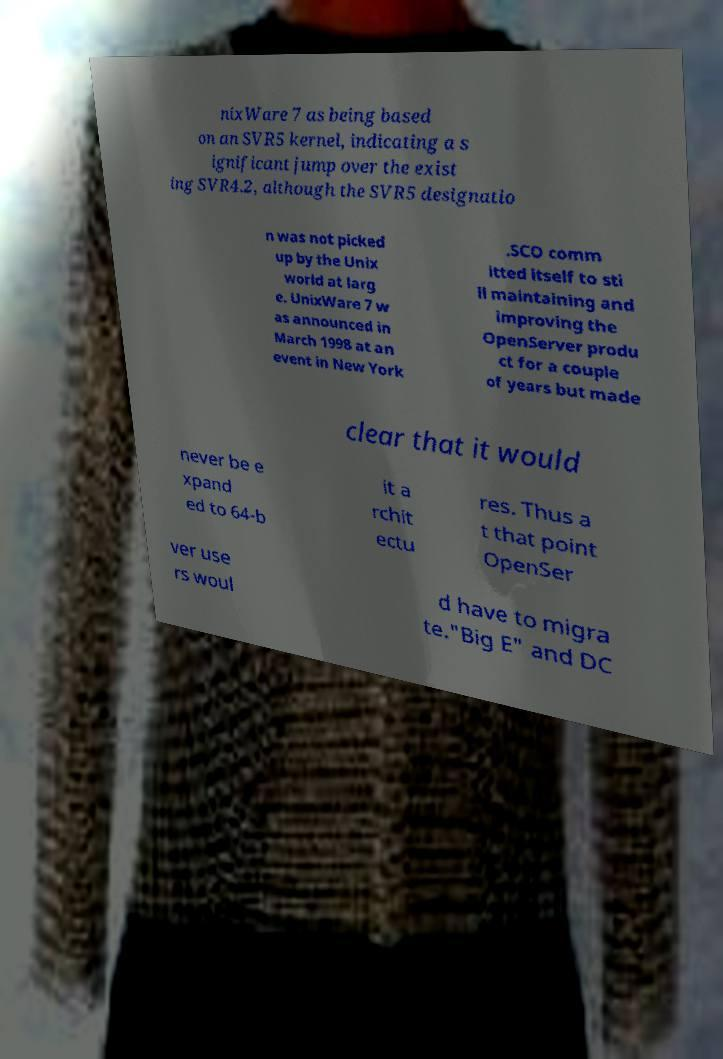What messages or text are displayed in this image? I need them in a readable, typed format. nixWare 7 as being based on an SVR5 kernel, indicating a s ignificant jump over the exist ing SVR4.2, although the SVR5 designatio n was not picked up by the Unix world at larg e. UnixWare 7 w as announced in March 1998 at an event in New York .SCO comm itted itself to sti ll maintaining and improving the OpenServer produ ct for a couple of years but made clear that it would never be e xpand ed to 64-b it a rchit ectu res. Thus a t that point OpenSer ver use rs woul d have to migra te."Big E" and DC 